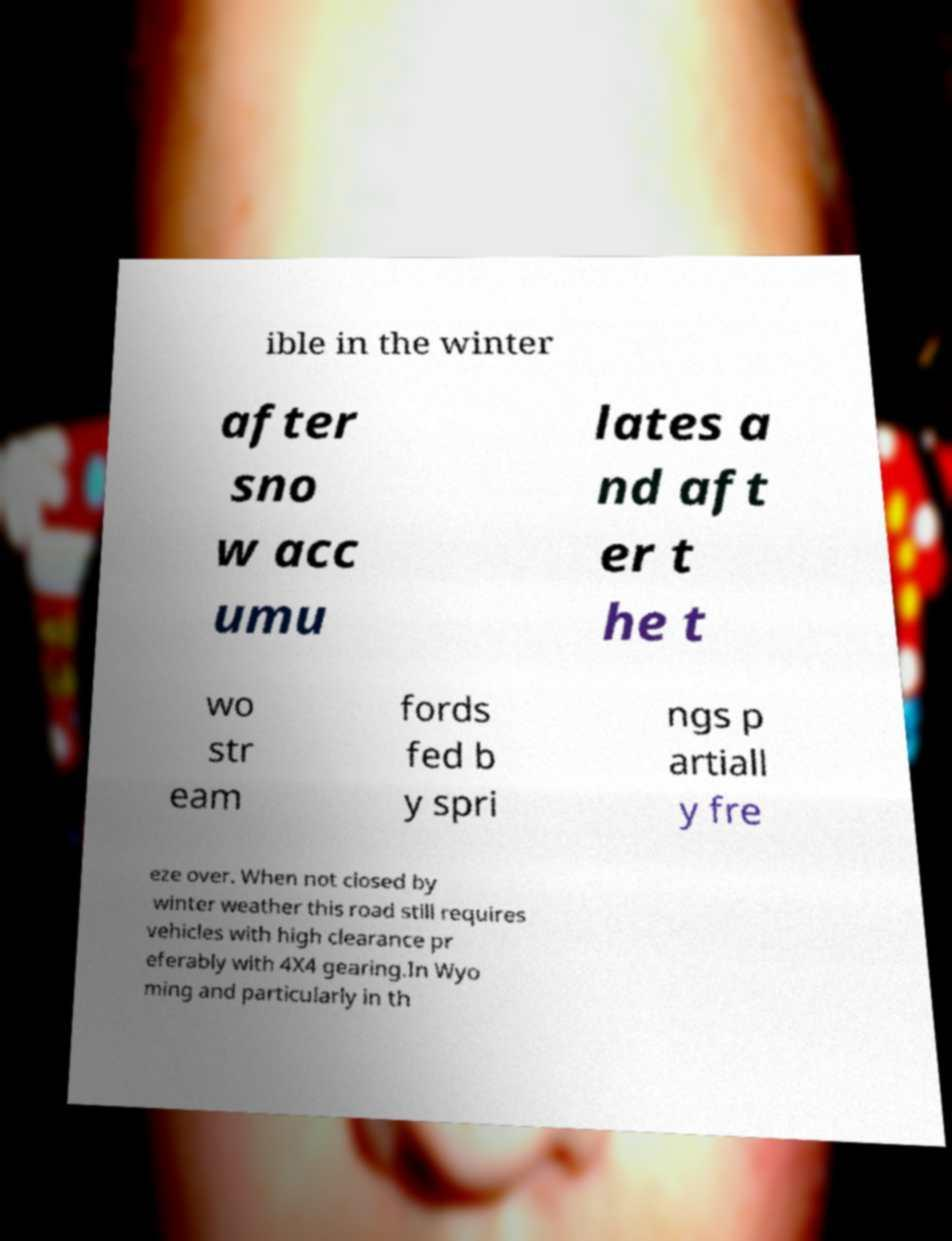There's text embedded in this image that I need extracted. Can you transcribe it verbatim? ible in the winter after sno w acc umu lates a nd aft er t he t wo str eam fords fed b y spri ngs p artiall y fre eze over. When not closed by winter weather this road still requires vehicles with high clearance pr eferably with 4X4 gearing.In Wyo ming and particularly in th 